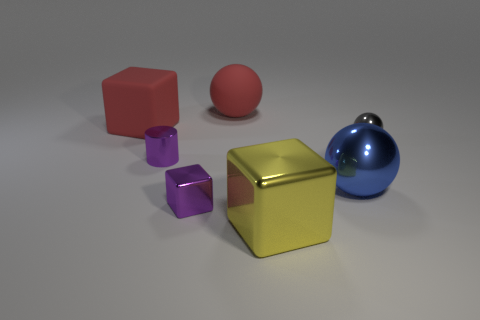The tiny metallic object that is the same color as the tiny cube is what shape?
Give a very brief answer. Cylinder. Do the purple cube and the cube on the left side of the tiny purple shiny cube have the same material?
Provide a short and direct response. No. How many large matte objects are behind the big rubber thing behind the red thing in front of the large red rubber ball?
Ensure brevity in your answer.  0. There is a tiny gray object; is it the same shape as the purple metallic thing that is in front of the blue ball?
Offer a very short reply. No. The object that is both to the right of the large red block and to the left of the small purple shiny block is what color?
Offer a terse response. Purple. There is a big cube that is to the right of the large red thing that is in front of the large sphere that is on the left side of the blue shiny thing; what is its material?
Provide a succinct answer. Metal. What material is the big red ball?
Offer a terse response. Rubber. There is a gray shiny thing that is the same shape as the blue thing; what size is it?
Your answer should be compact. Small. Does the big matte ball have the same color as the tiny shiny block?
Offer a very short reply. No. What number of other things are there of the same material as the blue ball
Ensure brevity in your answer.  4. 